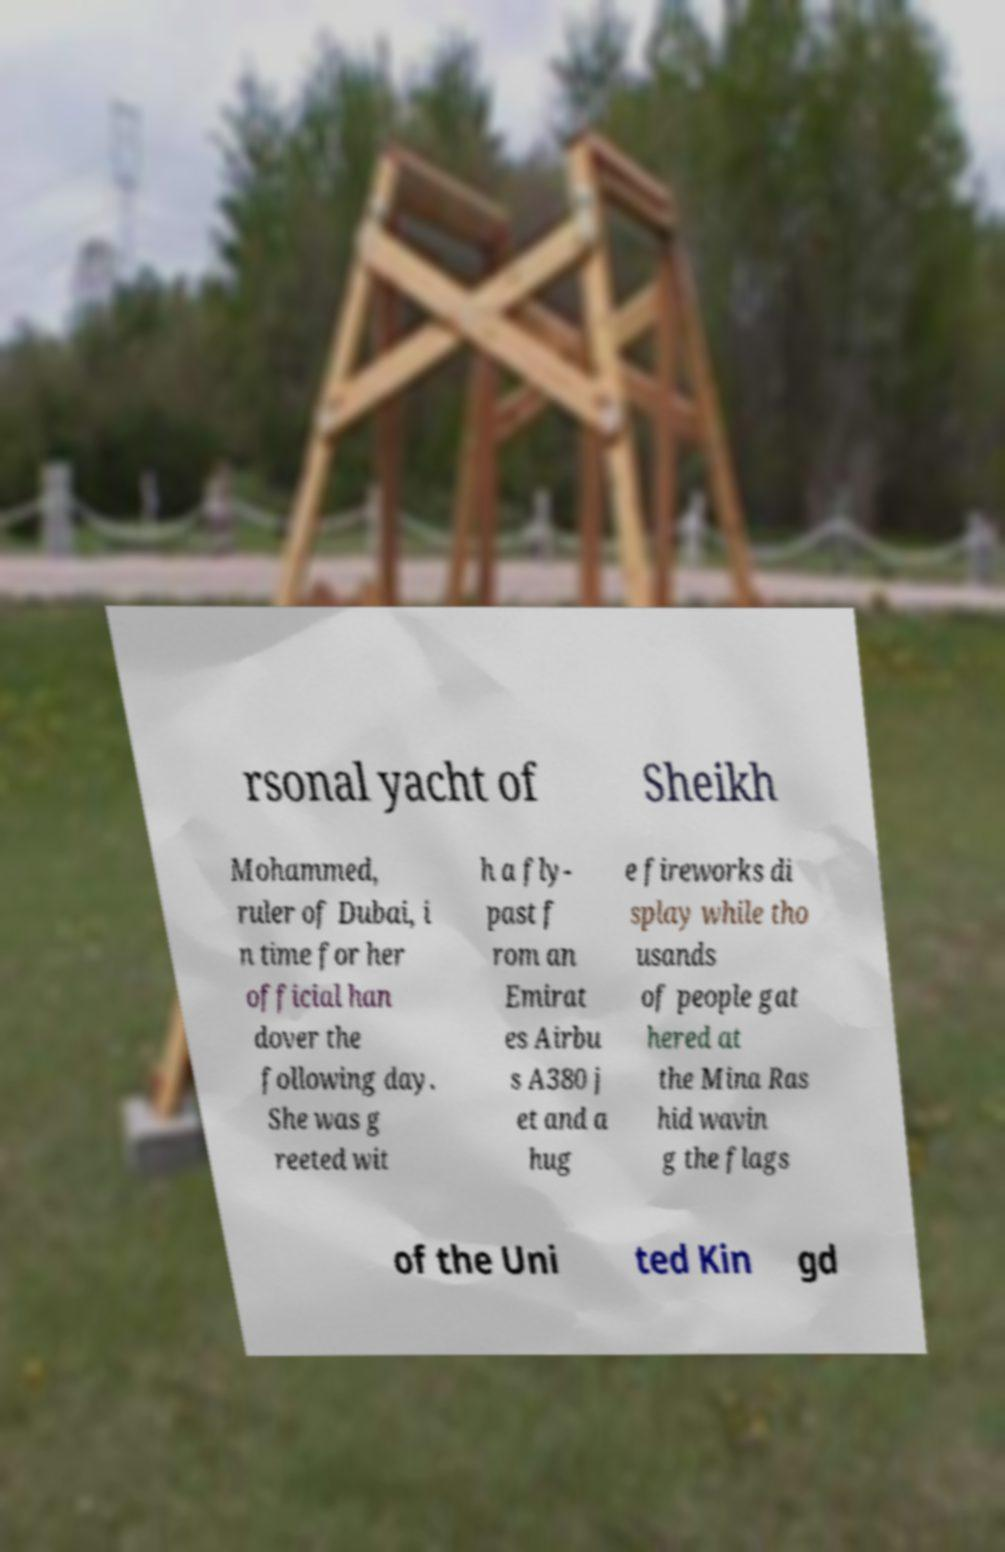Could you assist in decoding the text presented in this image and type it out clearly? rsonal yacht of Sheikh Mohammed, ruler of Dubai, i n time for her official han dover the following day. She was g reeted wit h a fly- past f rom an Emirat es Airbu s A380 j et and a hug e fireworks di splay while tho usands of people gat hered at the Mina Ras hid wavin g the flags of the Uni ted Kin gd 